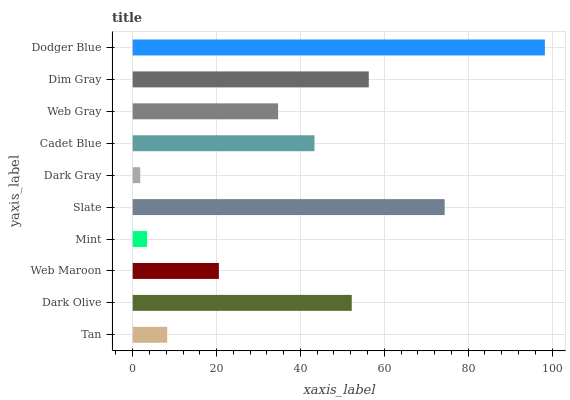Is Dark Gray the minimum?
Answer yes or no. Yes. Is Dodger Blue the maximum?
Answer yes or no. Yes. Is Dark Olive the minimum?
Answer yes or no. No. Is Dark Olive the maximum?
Answer yes or no. No. Is Dark Olive greater than Tan?
Answer yes or no. Yes. Is Tan less than Dark Olive?
Answer yes or no. Yes. Is Tan greater than Dark Olive?
Answer yes or no. No. Is Dark Olive less than Tan?
Answer yes or no. No. Is Cadet Blue the high median?
Answer yes or no. Yes. Is Web Gray the low median?
Answer yes or no. Yes. Is Dark Gray the high median?
Answer yes or no. No. Is Cadet Blue the low median?
Answer yes or no. No. 